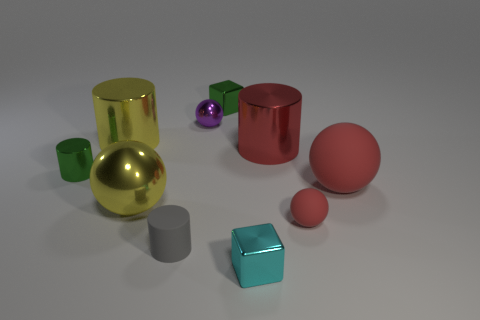Subtract all blocks. How many objects are left? 8 Add 4 large red shiny cylinders. How many large red shiny cylinders exist? 5 Subtract 0 gray cubes. How many objects are left? 10 Subtract all small purple metallic cylinders. Subtract all small balls. How many objects are left? 8 Add 5 yellow metallic balls. How many yellow metallic balls are left? 6 